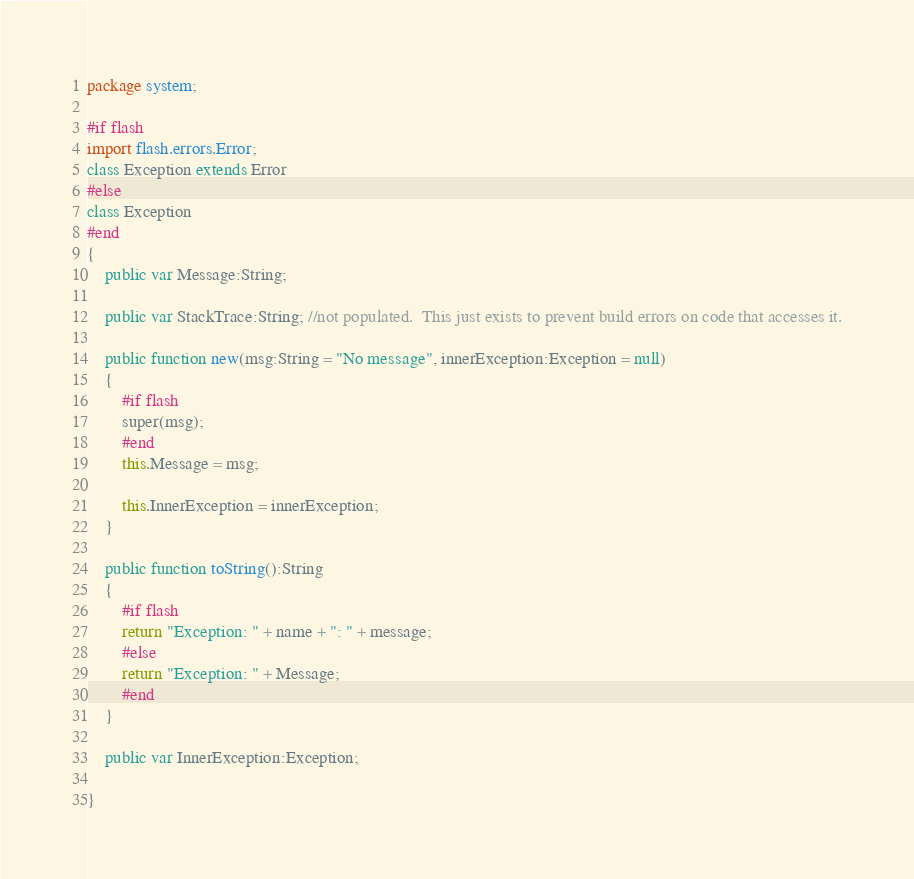Convert code to text. <code><loc_0><loc_0><loc_500><loc_500><_Haxe_>package system;

#if flash
import flash.errors.Error;
class Exception extends Error
#else
class Exception
#end
{
	public var Message:String;
	
	public var StackTrace:String; //not populated.  This just exists to prevent build errors on code that accesses it.
	
	public function new(msg:String = "No message", innerException:Exception = null)
	{
		#if flash
		super(msg);
		#end
		this.Message = msg;
		
		this.InnerException = innerException;
	}

	public function toString():String
	{
		#if flash
		return "Exception: " + name + ": " + message;
		#else
		return "Exception: " + Message;
		#end
	}
	
	public var InnerException:Exception;

}
</code> 